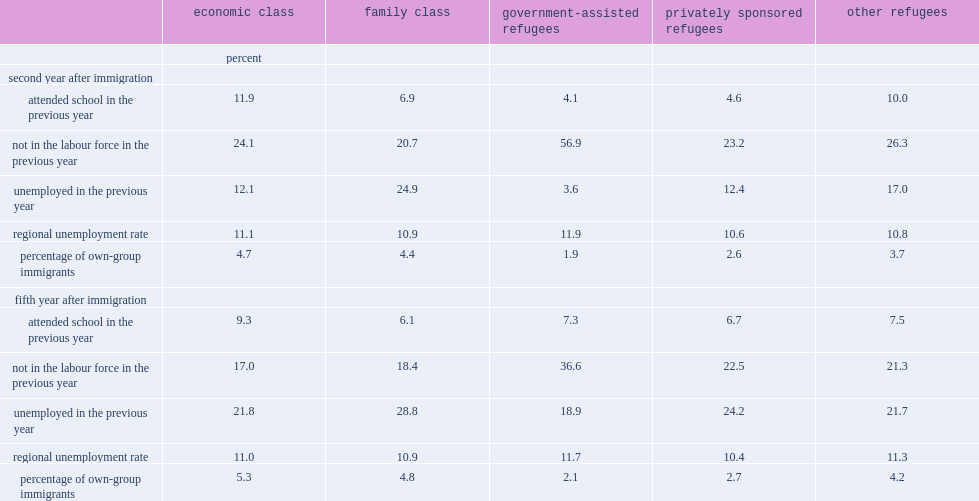What is the range of the non-labour force participation rates in year 2 for economic immigrants, family class immigrants, psrs and other refugees? 20.7 26.3. What is the percentage of gars not in the labour force in year 2? 56.9. Which class of immigrants have the highest unemployment rates in year 2, economic immigrants, psrs ,other refugees or family class immigrants? Family class. 